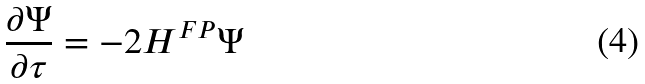Convert formula to latex. <formula><loc_0><loc_0><loc_500><loc_500>\frac { \partial \Psi } { \partial \tau } = - 2 H ^ { F P } \Psi</formula> 